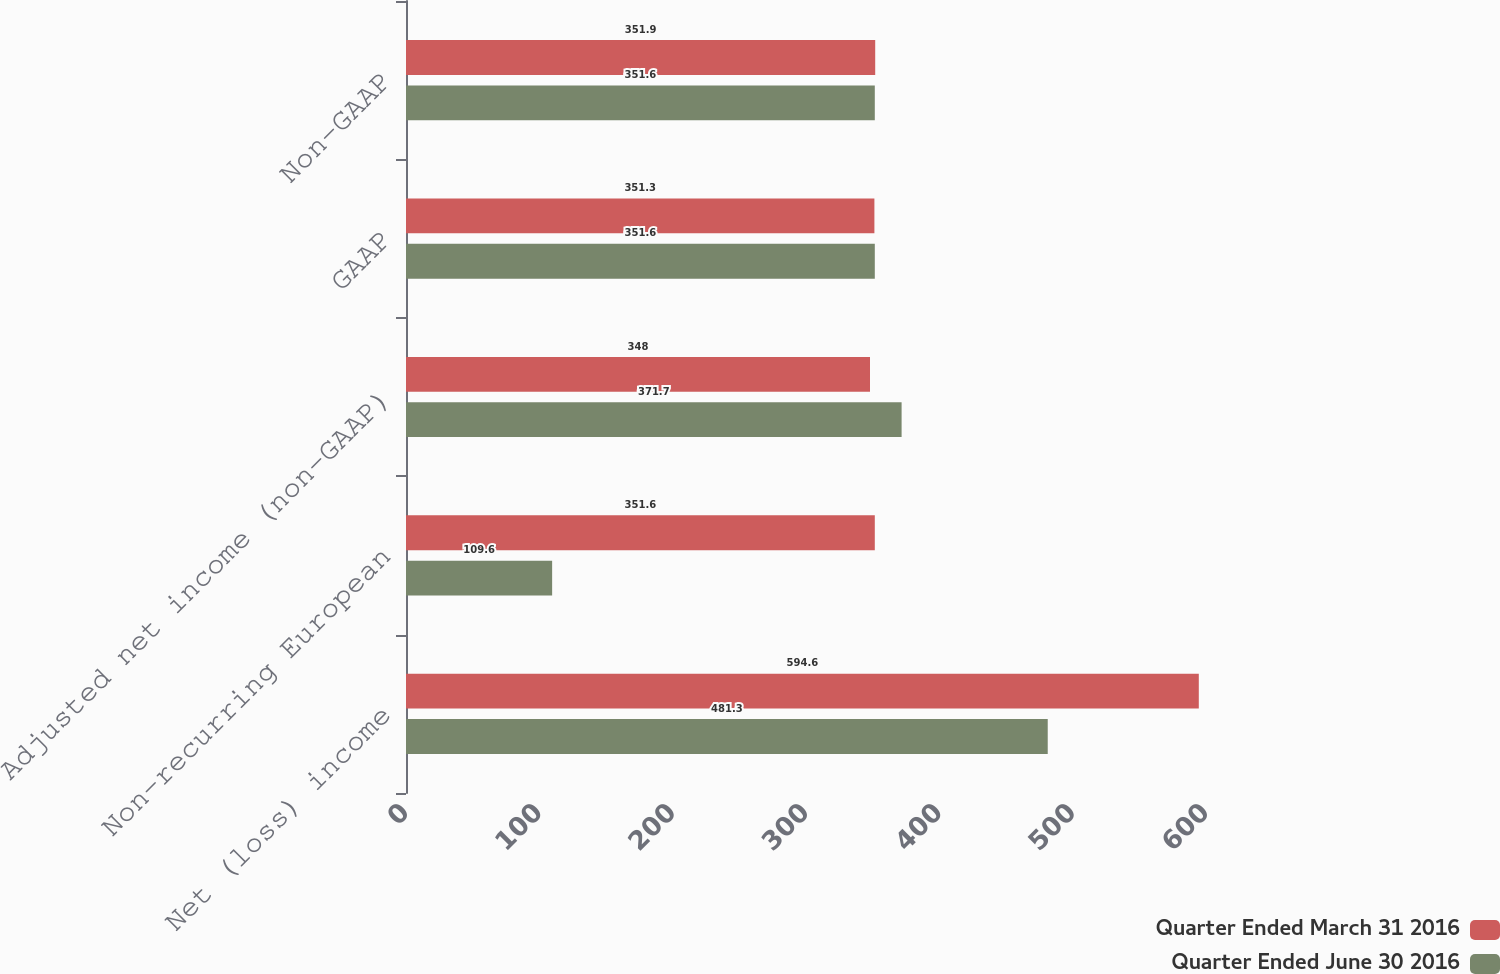Convert chart. <chart><loc_0><loc_0><loc_500><loc_500><stacked_bar_chart><ecel><fcel>Net (loss) income<fcel>Non-recurring European<fcel>Adjusted net income (non-GAAP)<fcel>GAAP<fcel>Non-GAAP<nl><fcel>Quarter Ended March 31 2016<fcel>594.6<fcel>351.6<fcel>348<fcel>351.3<fcel>351.9<nl><fcel>Quarter Ended June 30 2016<fcel>481.3<fcel>109.6<fcel>371.7<fcel>351.6<fcel>351.6<nl></chart> 